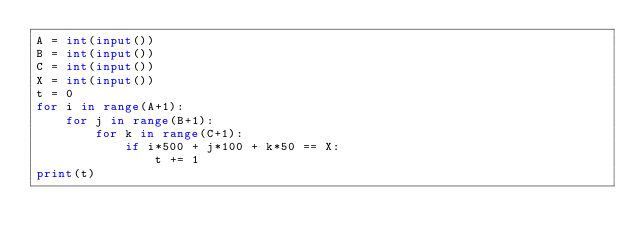<code> <loc_0><loc_0><loc_500><loc_500><_Python_>A = int(input())
B = int(input())
C = int(input())
X = int(input())
t = 0
for i in range(A+1):
    for j in range(B+1):
        for k in range(C+1):
            if i*500 + j*100 + k*50 == X:
                t += 1
print(t)
</code> 